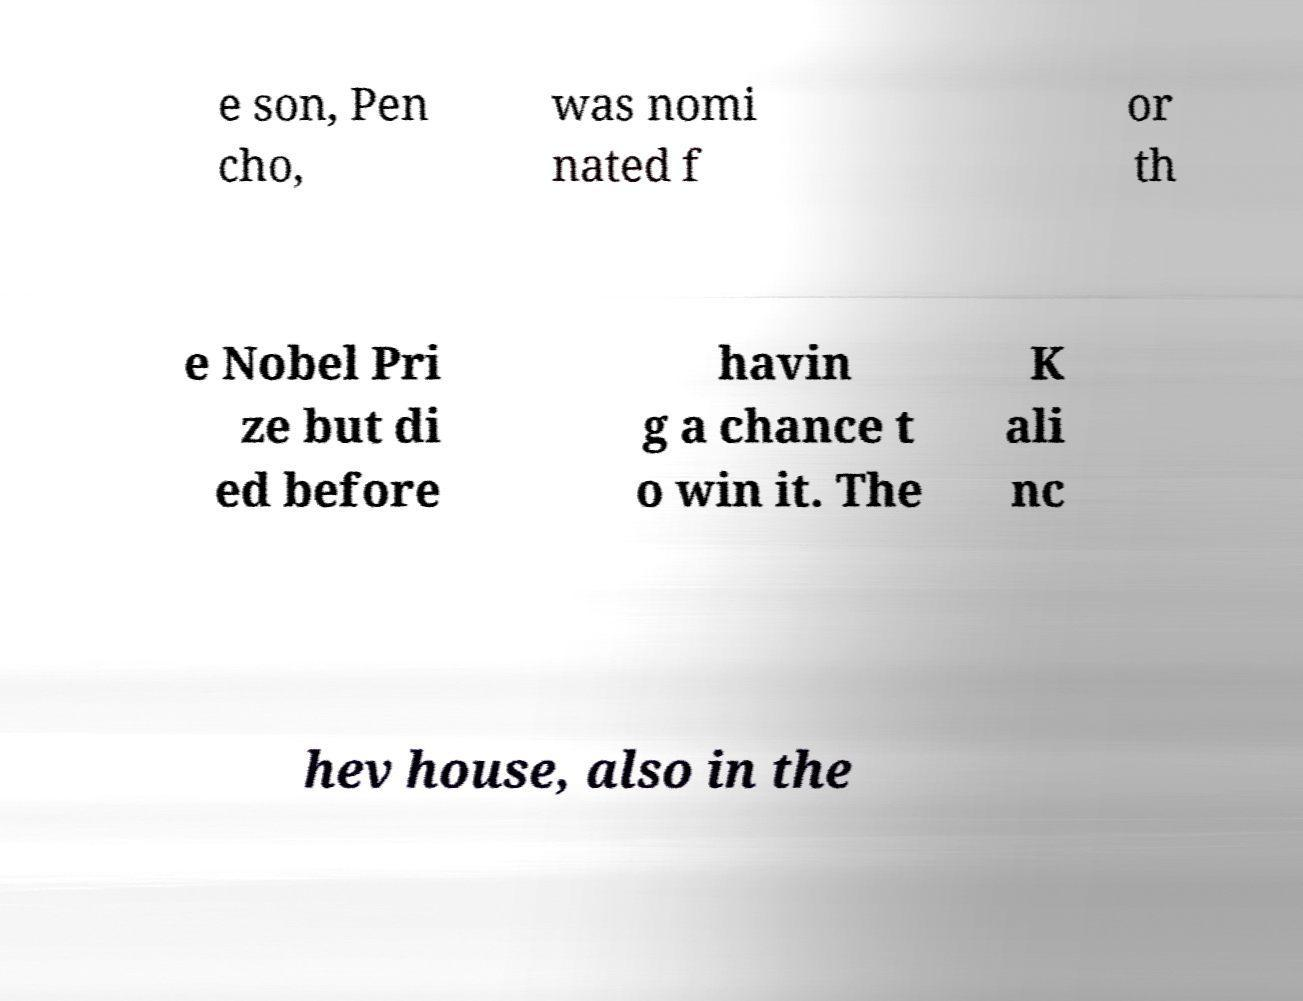I need the written content from this picture converted into text. Can you do that? e son, Pen cho, was nomi nated f or th e Nobel Pri ze but di ed before havin g a chance t o win it. The K ali nc hev house, also in the 